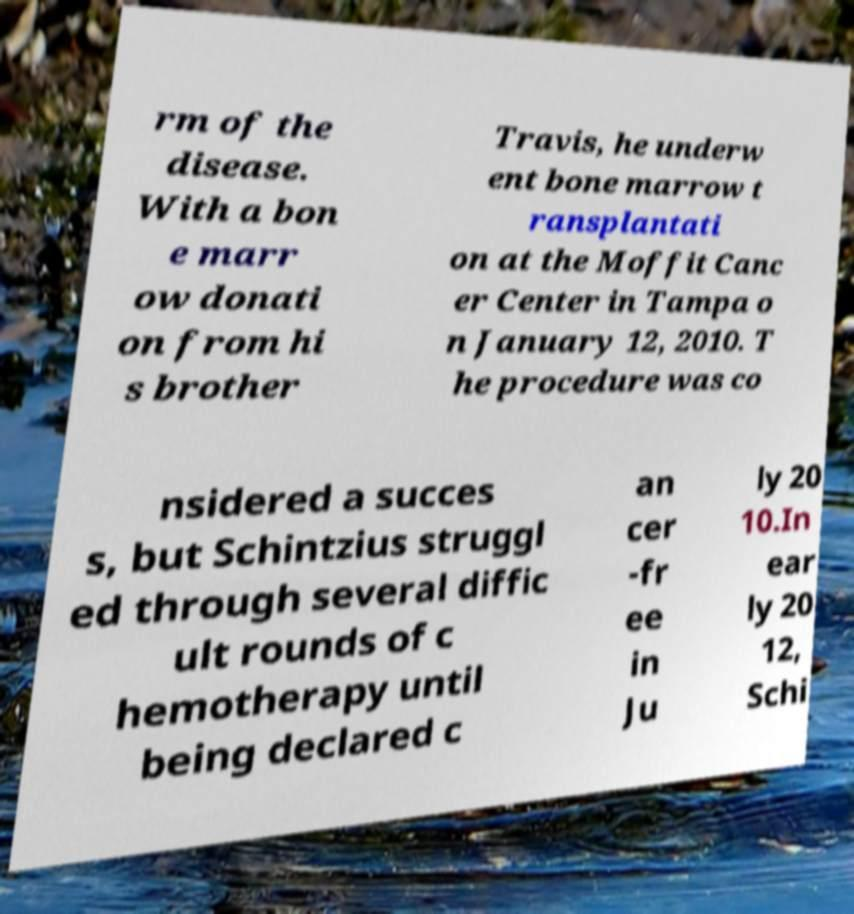Can you accurately transcribe the text from the provided image for me? rm of the disease. With a bon e marr ow donati on from hi s brother Travis, he underw ent bone marrow t ransplantati on at the Moffit Canc er Center in Tampa o n January 12, 2010. T he procedure was co nsidered a succes s, but Schintzius struggl ed through several diffic ult rounds of c hemotherapy until being declared c an cer -fr ee in Ju ly 20 10.In ear ly 20 12, Schi 